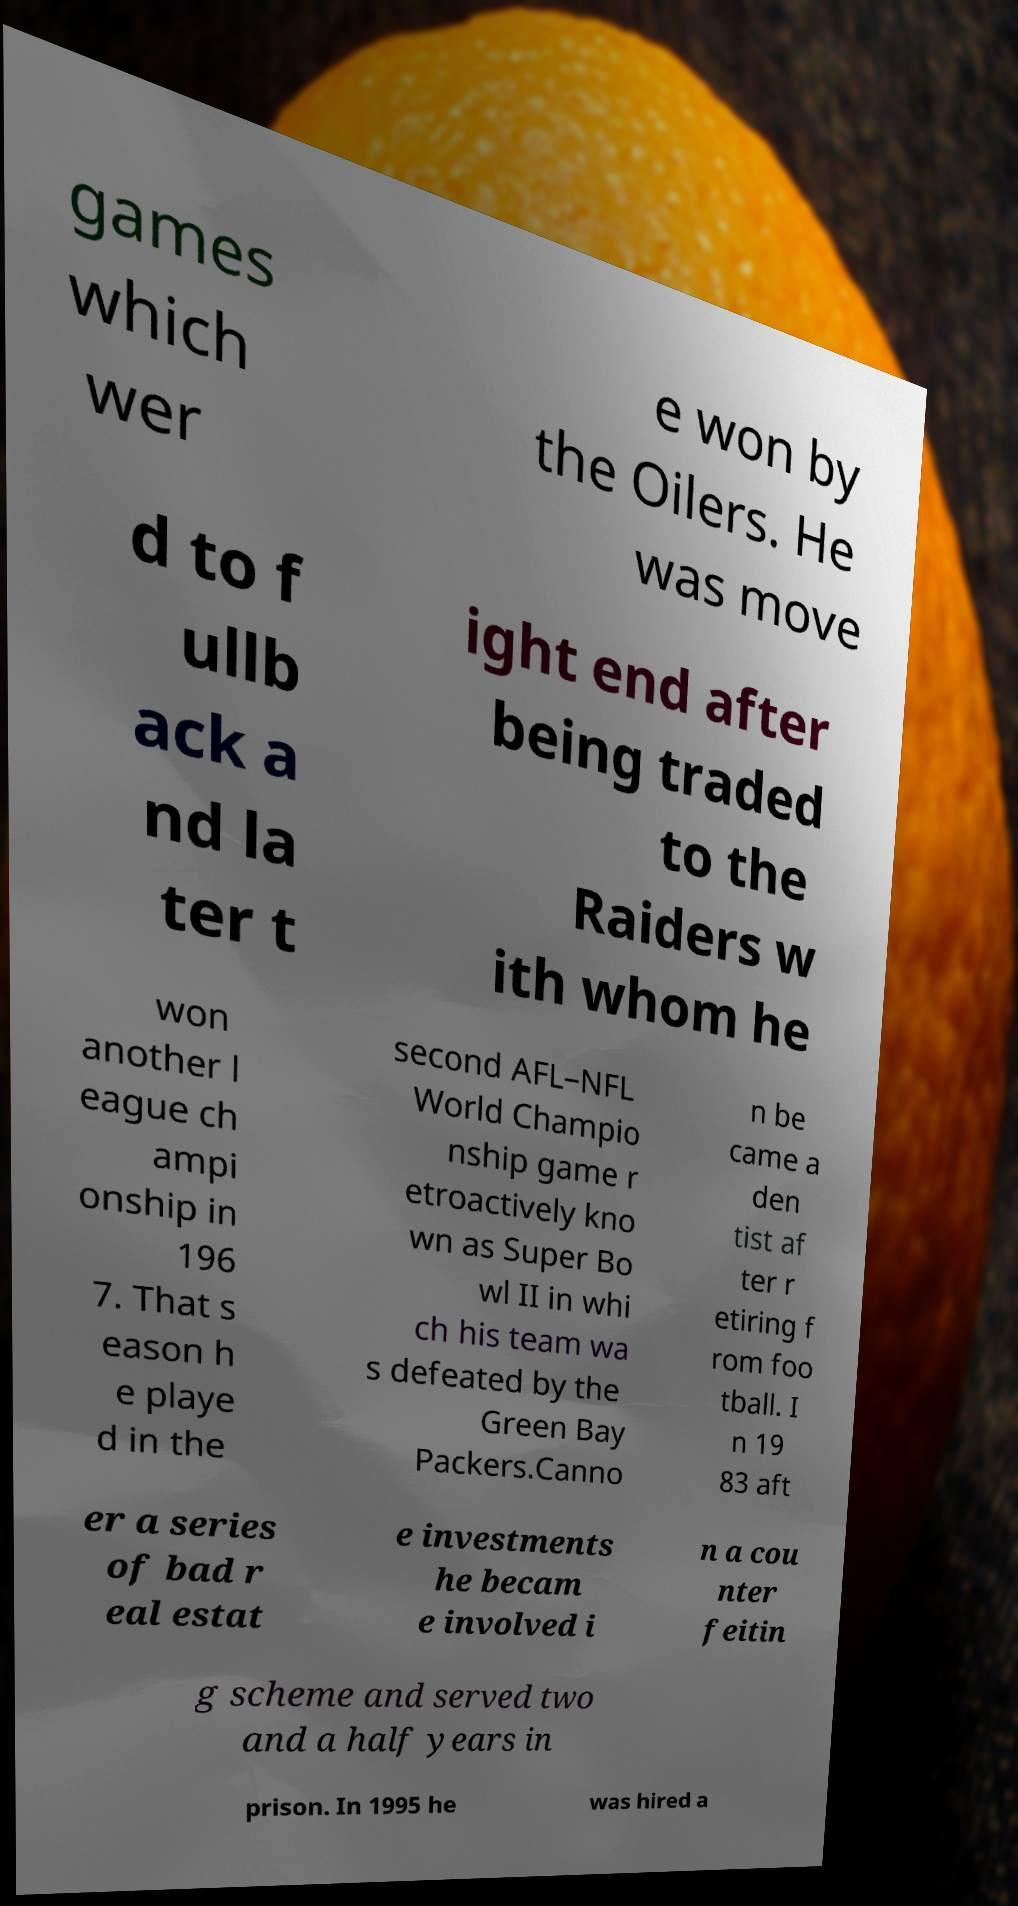What messages or text are displayed in this image? I need them in a readable, typed format. games which wer e won by the Oilers. He was move d to f ullb ack a nd la ter t ight end after being traded to the Raiders w ith whom he won another l eague ch ampi onship in 196 7. That s eason h e playe d in the second AFL–NFL World Champio nship game r etroactively kno wn as Super Bo wl II in whi ch his team wa s defeated by the Green Bay Packers.Canno n be came a den tist af ter r etiring f rom foo tball. I n 19 83 aft er a series of bad r eal estat e investments he becam e involved i n a cou nter feitin g scheme and served two and a half years in prison. In 1995 he was hired a 